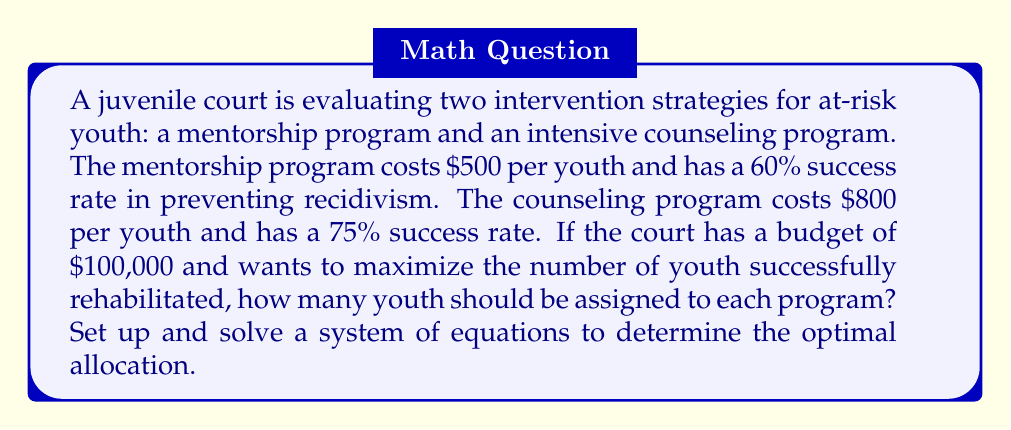Teach me how to tackle this problem. Let's approach this step-by-step:

1) Let $x$ be the number of youth in the mentorship program and $y$ be the number in the counseling program.

2) We can set up two equations based on the given information:

   Budget constraint: $500x + 800y = 100000$ (1)
   
   Maximizing successful rehabilitations: $0.60x + 0.75y = \text{max}$ (2)

3) Our goal is to maximize equation (2) subject to the constraint in equation (1).

4) We can solve equation (1) for $y$:

   $y = 125 - 0.625x$ (3)

5) Substituting (3) into (2):

   $0.60x + 0.75(125 - 0.625x) = 0.60x + 93.75 - 0.46875x$
   $0.13125x + 93.75 = \text{max}$

6) To maximize this, we want $x$ to be as large as possible while still satisfying the constraint.

7) The maximum value for $x$ occurs when $y = 0$ in equation (1):

   $500x = 100000$
   $x = 200$

8) Substituting $x = 200$ into equation (3):

   $y = 125 - 0.625(200) = 0$

Therefore, the optimal allocation is to assign all 200 youth to the mentorship program.

9) We can verify that this satisfies the budget:

   $500(200) + 800(0) = 100000$

10) The number of youth successfully rehabilitated would be:

    $0.60(200) + 0.75(0) = 120$

This is indeed the maximum possible given the constraints.
Answer: The optimal allocation is to assign 200 youth to the mentorship program and 0 to the counseling program, which would successfully rehabilitate 120 youth. 